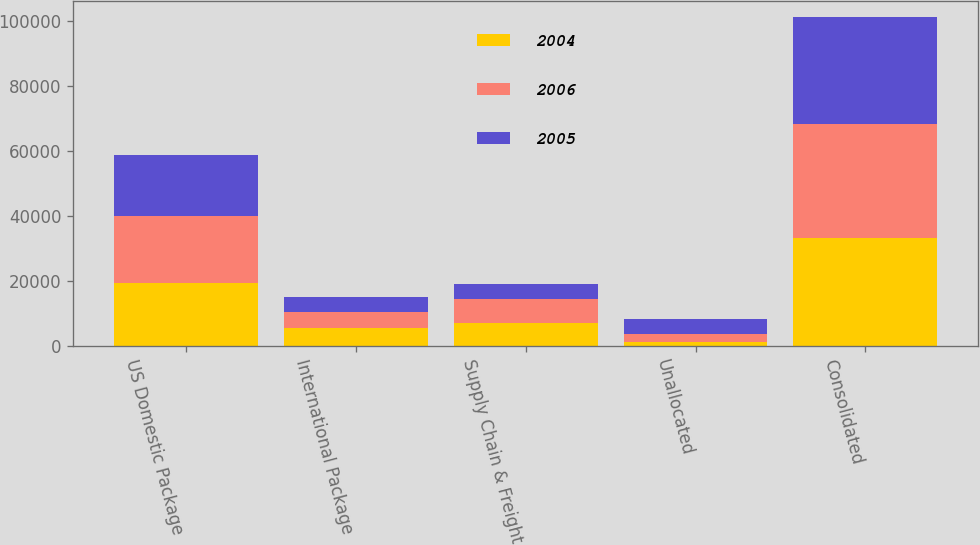Convert chart to OTSL. <chart><loc_0><loc_0><loc_500><loc_500><stacked_bar_chart><ecel><fcel>US Domestic Package<fcel>International Package<fcel>Supply Chain & Freight<fcel>Unallocated<fcel>Consolidated<nl><fcel>2004<fcel>19274<fcel>5496<fcel>7150<fcel>1290<fcel>33210<nl><fcel>2006<fcel>20572<fcel>4931<fcel>7116<fcel>2328<fcel>34947<nl><fcel>2005<fcel>18749<fcel>4682<fcel>4878<fcel>4538<fcel>32847<nl></chart> 